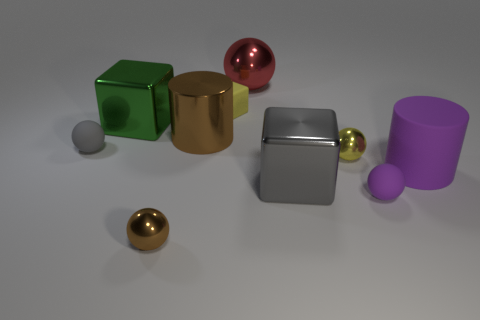There is a yellow object that is behind the big green object; what shape is it?
Your answer should be compact. Cube. How many small metallic balls have the same color as the small cube?
Provide a succinct answer. 1. What color is the big rubber cylinder?
Make the answer very short. Purple. There is a small matte ball that is behind the tiny purple object; how many green shiny things are in front of it?
Make the answer very short. 0. Is the size of the purple matte cylinder the same as the shiny ball behind the small gray sphere?
Offer a very short reply. Yes. Is the size of the yellow ball the same as the matte cube?
Give a very brief answer. Yes. Are there any shiny objects of the same size as the purple ball?
Provide a short and direct response. Yes. There is a brown object to the left of the metallic cylinder; what is it made of?
Offer a very short reply. Metal. What is the color of the other tiny sphere that is made of the same material as the brown ball?
Keep it short and to the point. Yellow. What number of shiny things are purple things or large brown objects?
Your response must be concise. 1. 